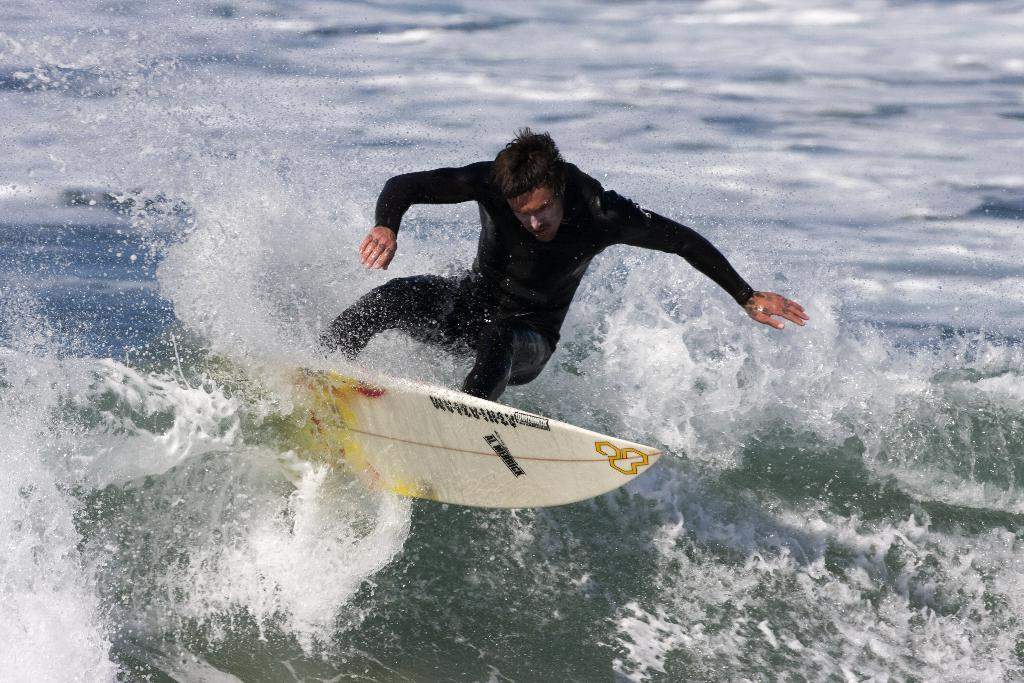Who is the main subject in the image? There is a man in the image. What is the man doing in the image? The man is surfing. What tool or equipment is the man using for surfing? The man is using a surfboard. What type of environment is visible in the image? There is water visible in the image. What type of orange can be seen in the image? There is no orange present in the image. What activity is the man participating in at the lake in the image? There is no lake present in the image, and the man is surfing in water, not participating in any activity at a lake. 